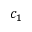<formula> <loc_0><loc_0><loc_500><loc_500>c _ { 1 }</formula> 